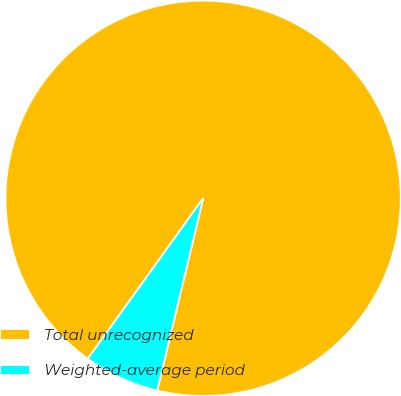Convert chart. <chart><loc_0><loc_0><loc_500><loc_500><pie_chart><fcel>Total unrecognized<fcel>Weighted-average period<nl><fcel>93.82%<fcel>6.18%<nl></chart> 